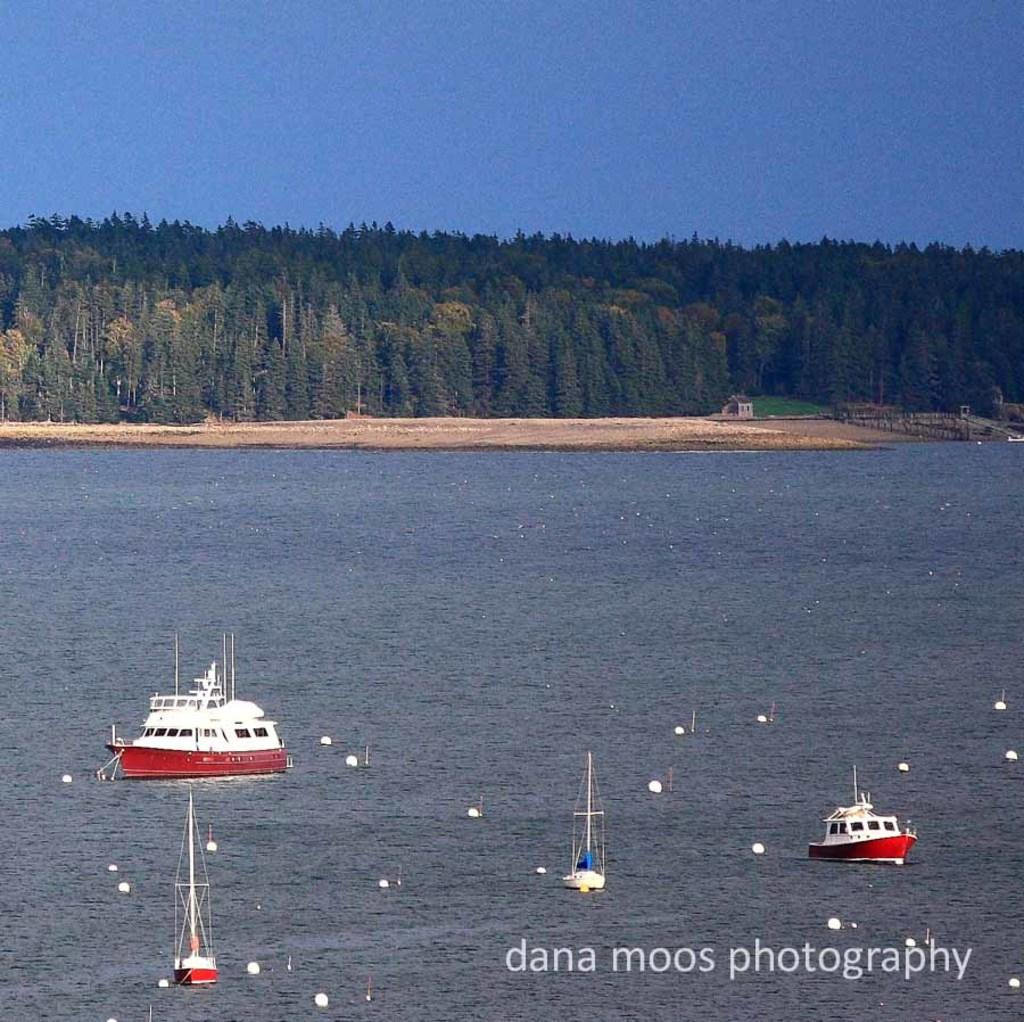Provide a one-sentence caption for the provided image. A boat can be seen on the water with a dana moos photography watermark in the corner. 